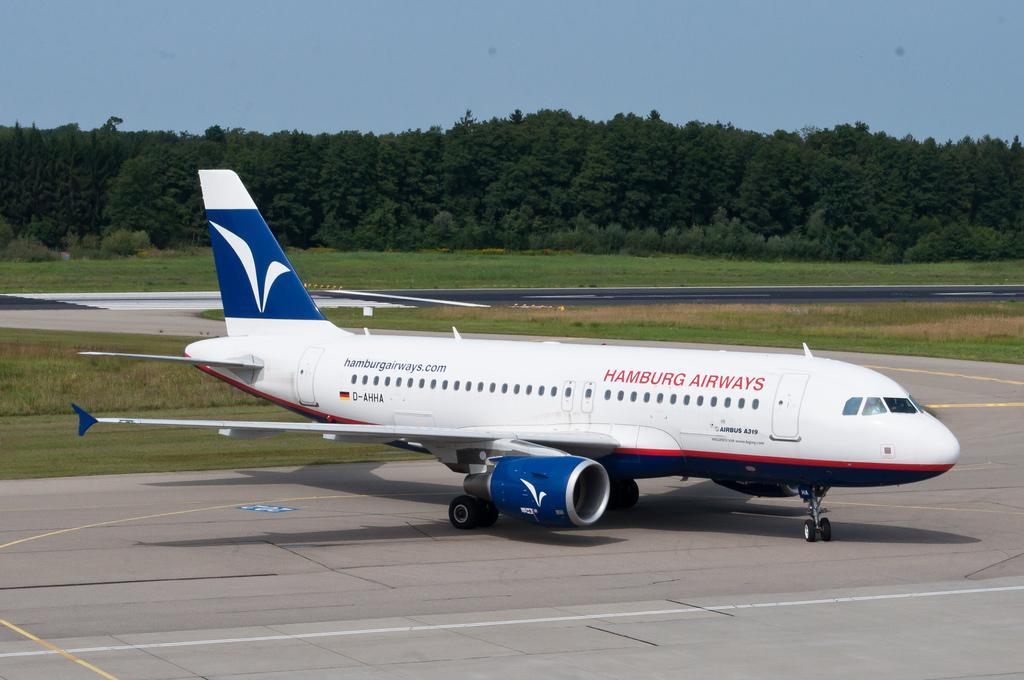In one or two sentences, can you explain what this image depicts? In this picture I can see a plane on the run way, around I can see some trees and grass. 